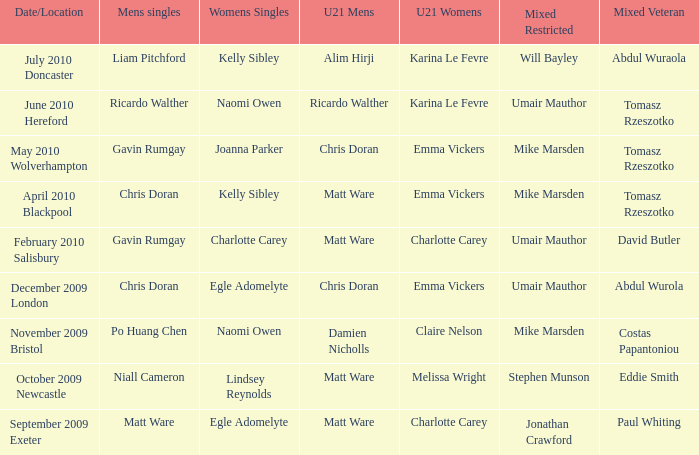When Paul Whiting won the mixed veteran, who won the mixed restricted? Jonathan Crawford. 